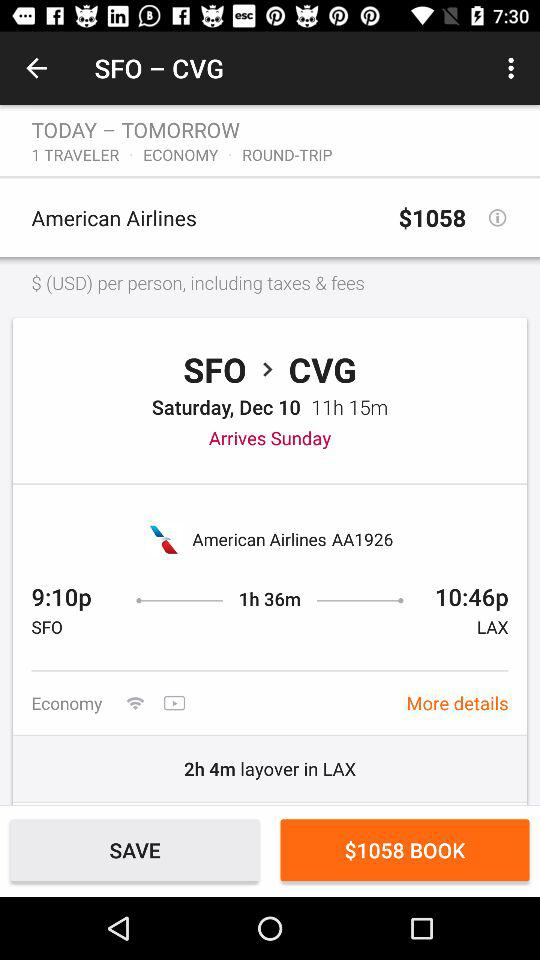How much is the "American Airlines" ticket price for the round trip from San Francisco to Cincinnati? The ticket price is $1058. 